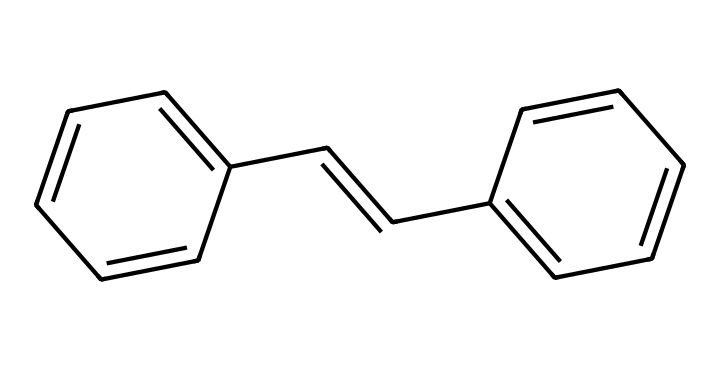What is the chemical formula of stilbene? The SMILES representation indicates there are 14 carbon atoms (C) and 12 hydrogen atoms (H), corresponding to the formula C14H12.
Answer: C14H12 How many double bonds are in the stilbene structure? Upon examining the structure derived from the SMILES, we can identify 6 double bonds (as seen in the multiple connections between the carbon atoms).
Answer: 6 What type of isomerism is exhibited by stilbene? Stilbene exhibits geometric isomerism due to the restricted rotation around the double bonds, allowing for cis and trans configurations.
Answer: geometric isomerism What is the most likely geometric isomer of stilbene used in pigments? The trans isomer of stilbene is more commonly used due to its stability and different fluorescent properties compared to the cis isomer.
Answer: trans How does geometric isomerism affect the color of pigments in art restoration? The configuration (cis or trans) of stilbene correlates with the absorption and emission of light, thus affecting the color perceived in pigments.
Answer: color What are the common applications of stilbene in art restoration? Stilbene compounds, particularly those in their geometric forms, are utilized as fluorescent brighteners to enhance color vibrancy in artwork restoration.
Answer: fluorescent brighteners 